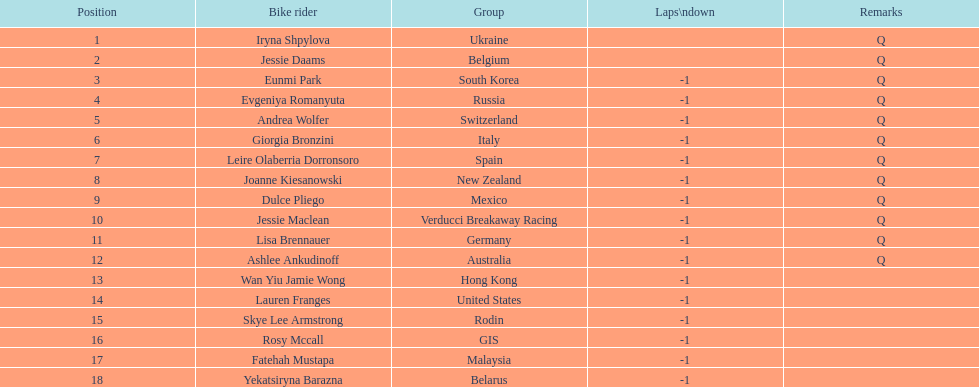Who was the first competitor to finish the race a lap behind? Eunmi Park. 